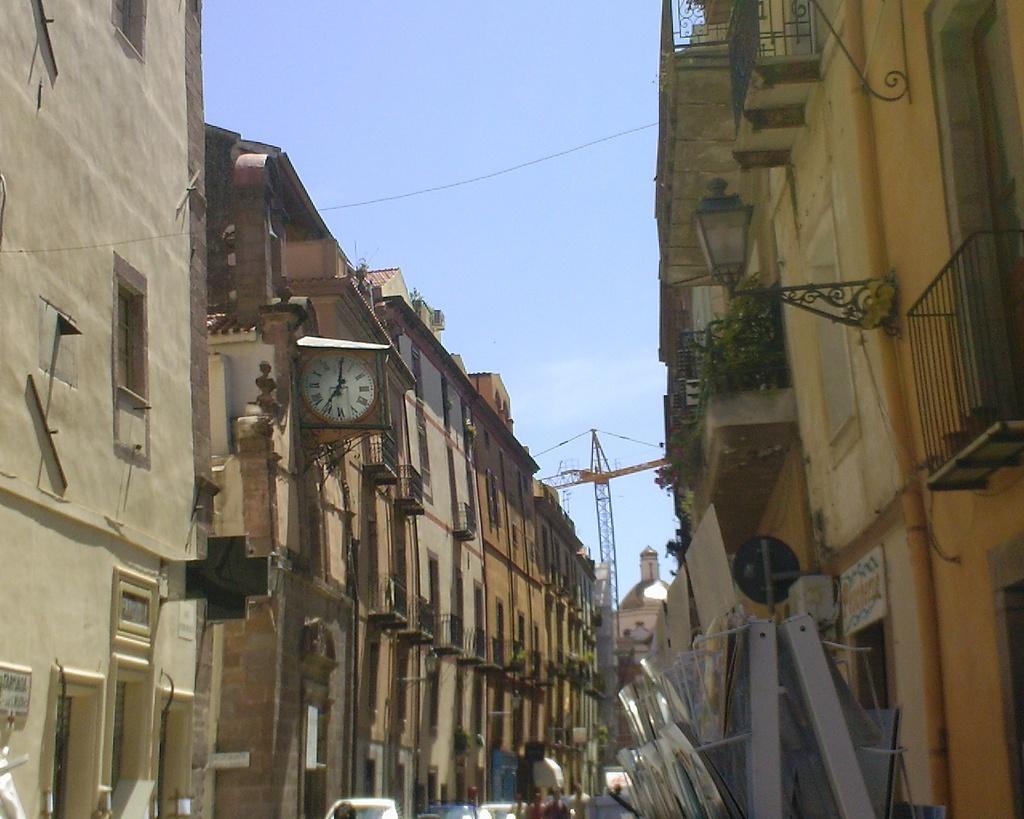Describe this image in one or two sentences. In this image there are buildings. At the bottom there are cars and people. In the center we can see a crane. At the top there is sky. 